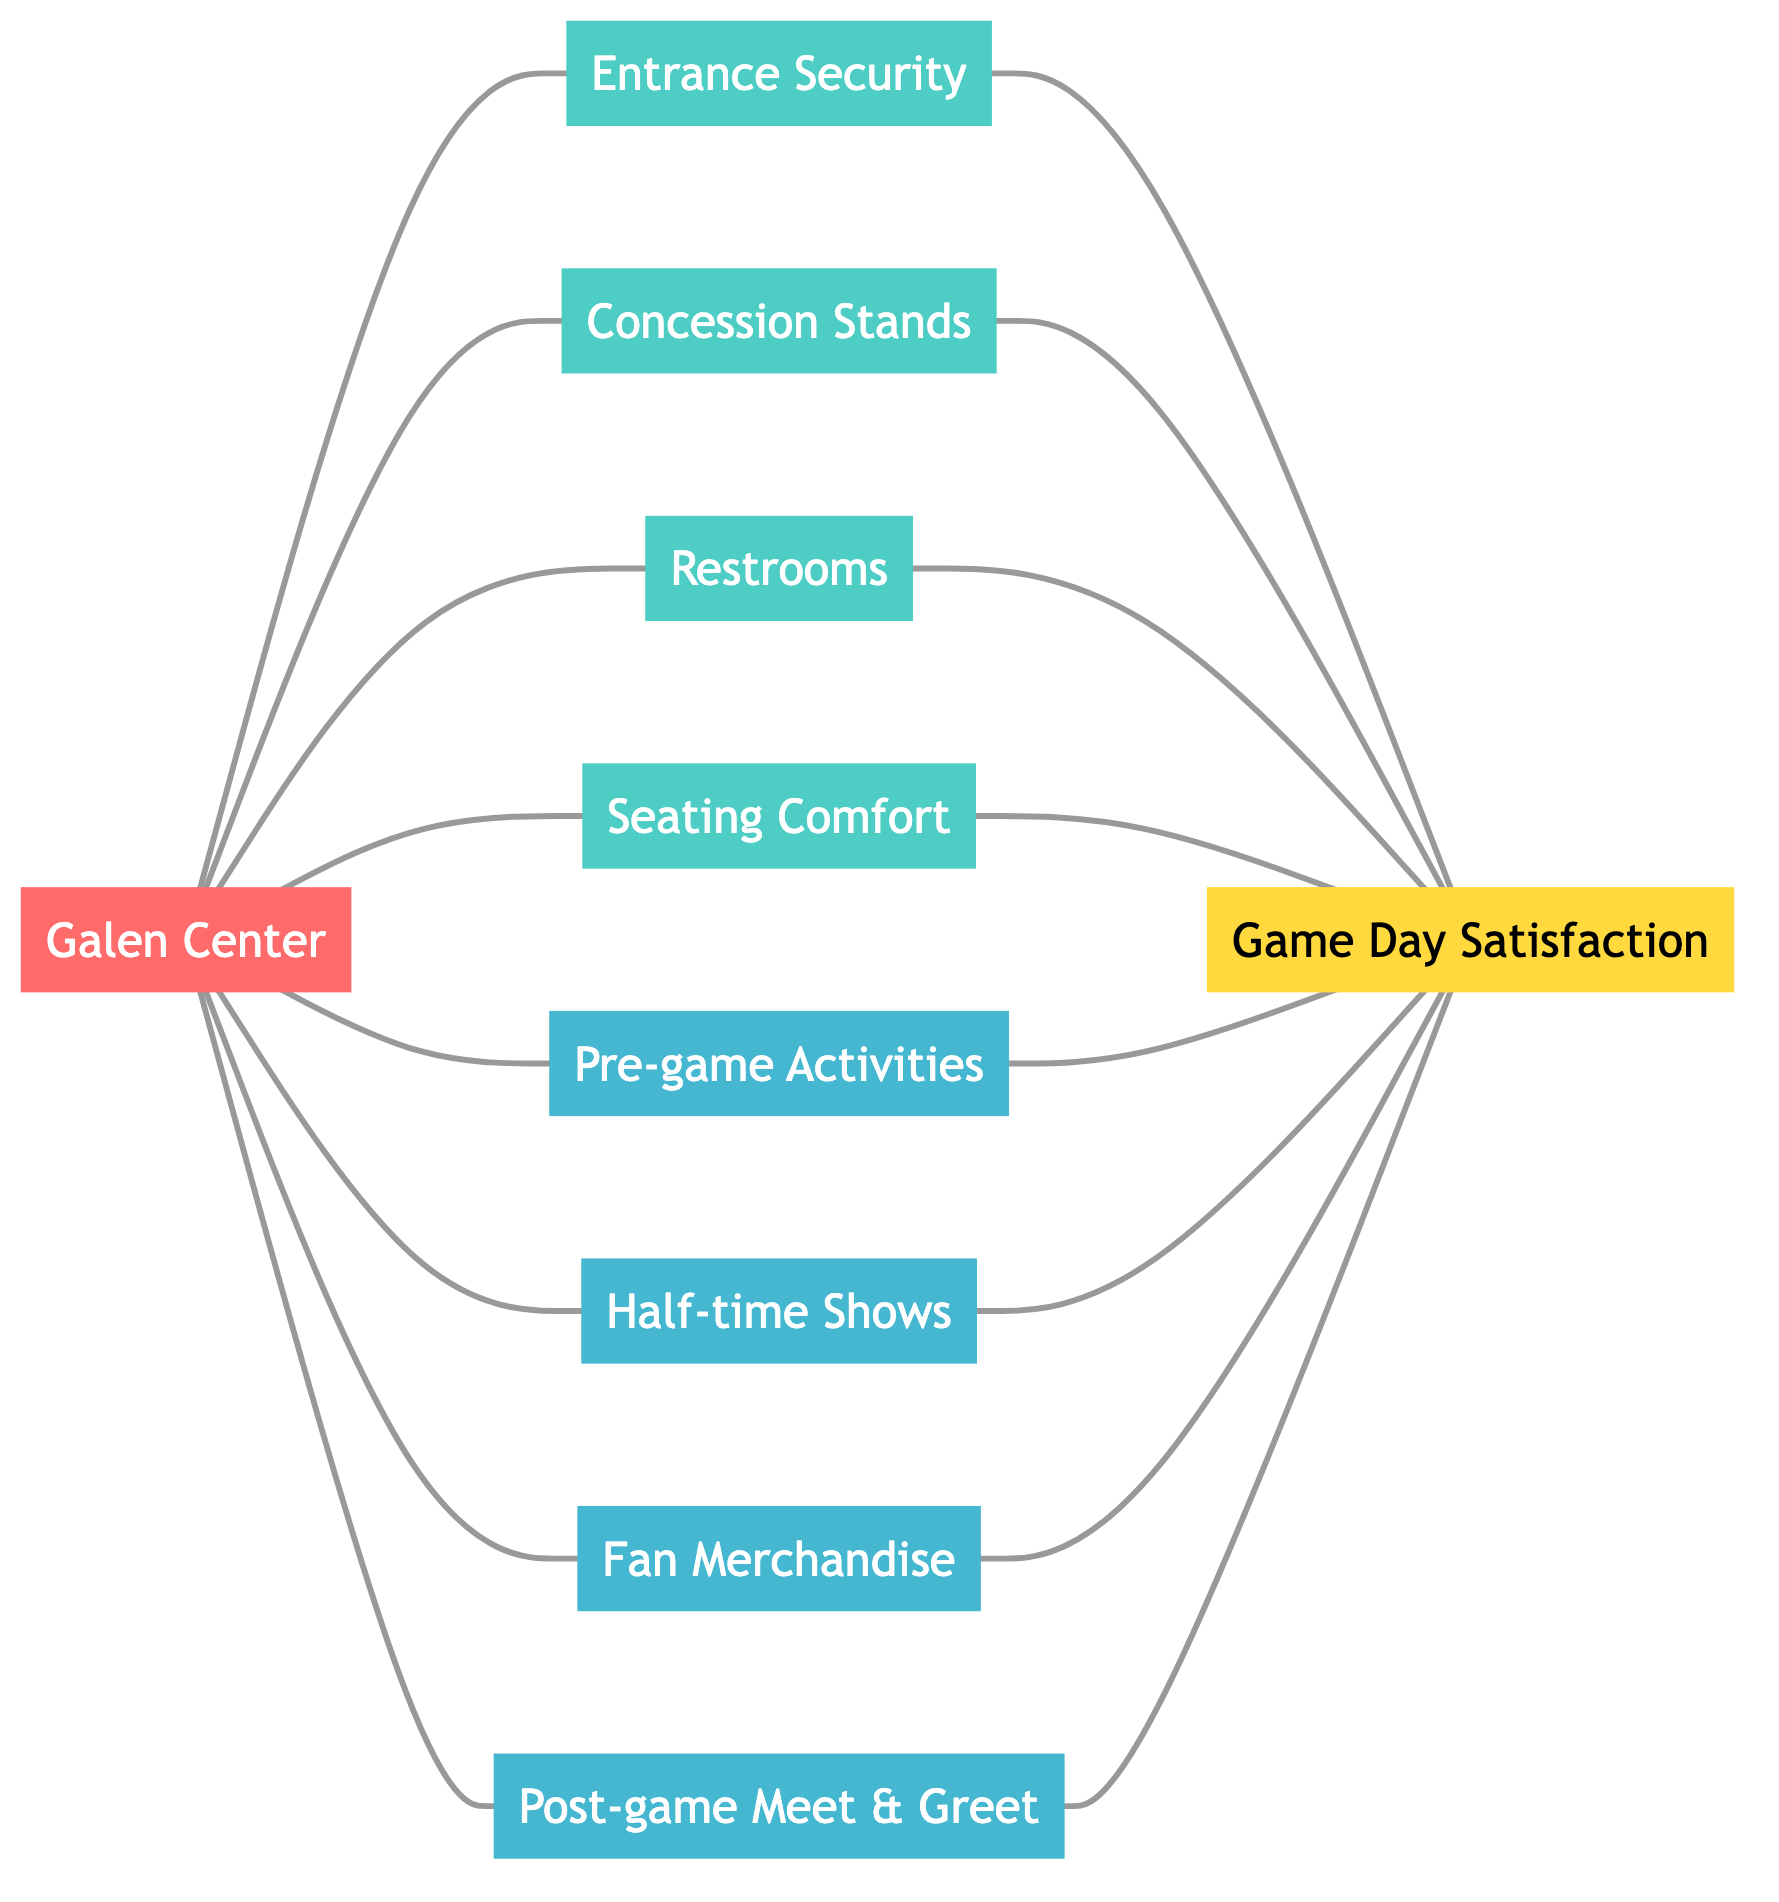What are the two types of engagement activities shown in the diagram? The diagram includes fan engagement activities categorized under two labels, which are "Pre-game Activities" and "Half-time Shows".
Answer: Pre-game Activities, Half-time Shows How many facilities are connected to the Galen Center? By examining the edges that connect directly to the node "Galen Center", we can count the facilities connected: Entrance Security, Concession Stands, Restrooms, and Seating Comfort, totaling four facilities.
Answer: 4 What is the node that represents overall game day satisfaction? The node connected to various fan engagement and facilities nodes, described with the label "Game Day Satisfaction", is the one representing overall satisfaction.
Answer: Game Day Satisfaction Which node is the closest to 'Restrooms'? The connections from "Restrooms" indicate it links directly to "Game Day Satisfaction", thus the closest node is the one it connects with directly based on the edges.
Answer: Game Day Satisfaction How many total nodes are represented in the diagram? Counting all unique nodes listed in the data, there are ten nodes: Galen Center, Entrance Security, Concession Stands, Restrooms, Seating Comfort, Pre-game Activities, Half-time Shows, Fan Merchandise, Post-game Meet & Greet, and Game Day Satisfaction.
Answer: 10 Which facilities contribute to game day satisfaction? The diagram specifies several facilities that connect to the "Game Day Satisfaction" node including Entrance Security, Concession Stands, Restrooms, and Seating Comfort, linking them directly to overall satisfaction.
Answer: Entrance Security, Concession Stands, Restrooms, Seating Comfort What type of graph is represented by this diagram? The presence of edges connecting nodes without direction indicates the nature of the graph, which involves connectivity between entities such as facilities and fan engagement activities.
Answer: Undirected Graph Which fan engagement activity is connected to overall satisfaction? The diagram shows connections from the node "Half-time Shows" to "Game Day Satisfaction", meaning this fan engagement activity plays a role in overall satisfaction.
Answer: Half-time Shows 